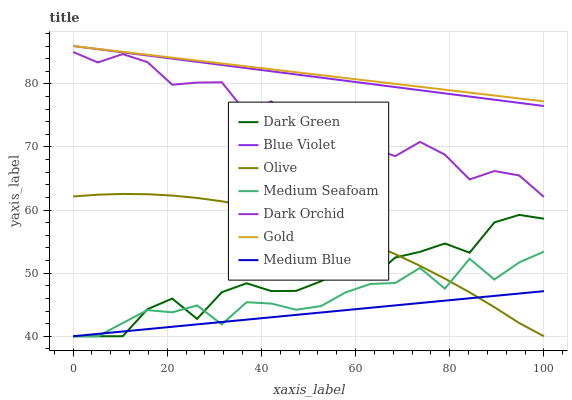Does Medium Blue have the minimum area under the curve?
Answer yes or no. Yes. Does Gold have the maximum area under the curve?
Answer yes or no. Yes. Does Dark Orchid have the minimum area under the curve?
Answer yes or no. No. Does Dark Orchid have the maximum area under the curve?
Answer yes or no. No. Is Gold the smoothest?
Answer yes or no. Yes. Is Dark Orchid the roughest?
Answer yes or no. Yes. Is Medium Blue the smoothest?
Answer yes or no. No. Is Medium Blue the roughest?
Answer yes or no. No. Does Medium Blue have the lowest value?
Answer yes or no. Yes. Does Dark Orchid have the lowest value?
Answer yes or no. No. Does Blue Violet have the highest value?
Answer yes or no. Yes. Does Dark Orchid have the highest value?
Answer yes or no. No. Is Dark Green less than Blue Violet?
Answer yes or no. Yes. Is Gold greater than Dark Green?
Answer yes or no. Yes. Does Olive intersect Dark Green?
Answer yes or no. Yes. Is Olive less than Dark Green?
Answer yes or no. No. Is Olive greater than Dark Green?
Answer yes or no. No. Does Dark Green intersect Blue Violet?
Answer yes or no. No. 